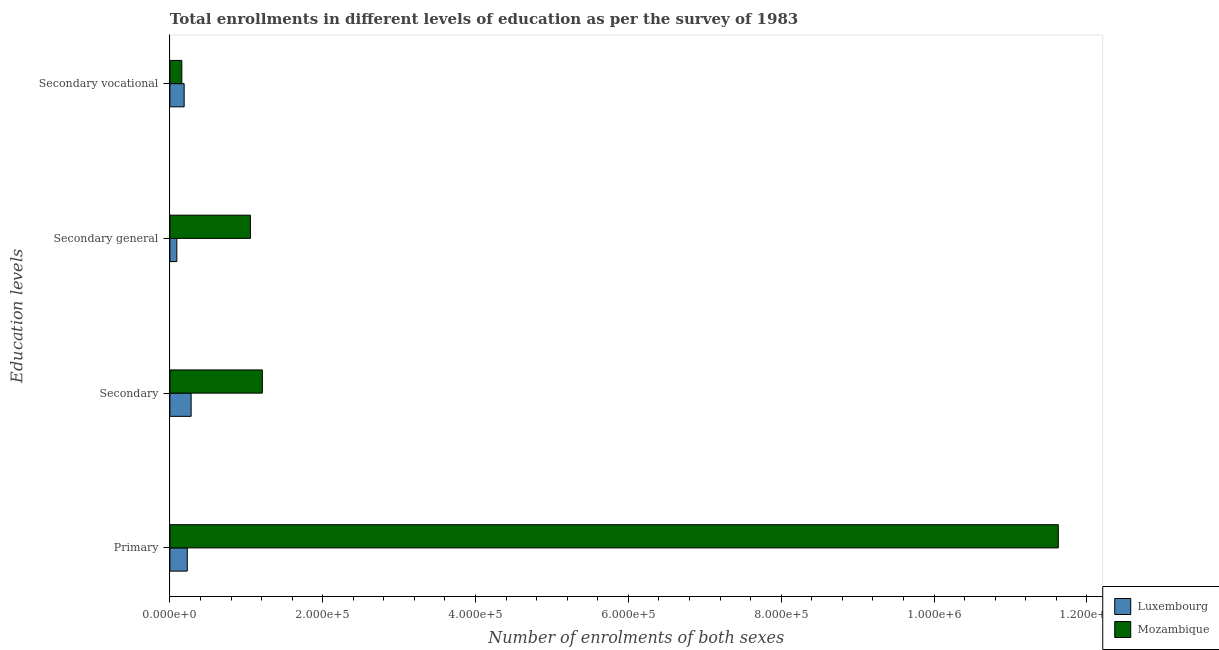Are the number of bars per tick equal to the number of legend labels?
Provide a succinct answer. Yes. Are the number of bars on each tick of the Y-axis equal?
Keep it short and to the point. Yes. How many bars are there on the 2nd tick from the top?
Ensure brevity in your answer.  2. How many bars are there on the 4th tick from the bottom?
Offer a very short reply. 2. What is the label of the 1st group of bars from the top?
Keep it short and to the point. Secondary vocational. What is the number of enrolments in secondary general education in Mozambique?
Provide a short and direct response. 1.05e+05. Across all countries, what is the maximum number of enrolments in primary education?
Keep it short and to the point. 1.16e+06. Across all countries, what is the minimum number of enrolments in primary education?
Offer a terse response. 2.28e+04. In which country was the number of enrolments in secondary general education maximum?
Ensure brevity in your answer.  Mozambique. In which country was the number of enrolments in secondary general education minimum?
Ensure brevity in your answer.  Luxembourg. What is the total number of enrolments in secondary education in the graph?
Your answer should be very brief. 1.49e+05. What is the difference between the number of enrolments in secondary vocational education in Luxembourg and that in Mozambique?
Keep it short and to the point. 3048. What is the difference between the number of enrolments in primary education in Mozambique and the number of enrolments in secondary education in Luxembourg?
Give a very brief answer. 1.13e+06. What is the average number of enrolments in secondary vocational education per country?
Provide a short and direct response. 1.72e+04. What is the difference between the number of enrolments in secondary education and number of enrolments in secondary vocational education in Luxembourg?
Ensure brevity in your answer.  9120. What is the ratio of the number of enrolments in secondary education in Luxembourg to that in Mozambique?
Your response must be concise. 0.23. Is the number of enrolments in secondary vocational education in Luxembourg less than that in Mozambique?
Keep it short and to the point. No. What is the difference between the highest and the second highest number of enrolments in primary education?
Offer a terse response. 1.14e+06. What is the difference between the highest and the lowest number of enrolments in secondary general education?
Provide a short and direct response. 9.63e+04. In how many countries, is the number of enrolments in primary education greater than the average number of enrolments in primary education taken over all countries?
Ensure brevity in your answer.  1. Is the sum of the number of enrolments in secondary vocational education in Mozambique and Luxembourg greater than the maximum number of enrolments in primary education across all countries?
Provide a succinct answer. No. Is it the case that in every country, the sum of the number of enrolments in secondary education and number of enrolments in primary education is greater than the sum of number of enrolments in secondary general education and number of enrolments in secondary vocational education?
Offer a very short reply. No. What does the 1st bar from the top in Secondary vocational represents?
Offer a very short reply. Mozambique. What does the 2nd bar from the bottom in Secondary represents?
Your answer should be very brief. Mozambique. Is it the case that in every country, the sum of the number of enrolments in primary education and number of enrolments in secondary education is greater than the number of enrolments in secondary general education?
Your response must be concise. Yes. How many bars are there?
Give a very brief answer. 8. How many countries are there in the graph?
Offer a terse response. 2. What is the difference between two consecutive major ticks on the X-axis?
Your answer should be very brief. 2.00e+05. Does the graph contain grids?
Your answer should be very brief. No. Where does the legend appear in the graph?
Offer a terse response. Bottom right. How many legend labels are there?
Your answer should be very brief. 2. How are the legend labels stacked?
Offer a very short reply. Vertical. What is the title of the graph?
Your answer should be compact. Total enrollments in different levels of education as per the survey of 1983. Does "Azerbaijan" appear as one of the legend labels in the graph?
Provide a succinct answer. No. What is the label or title of the X-axis?
Offer a terse response. Number of enrolments of both sexes. What is the label or title of the Y-axis?
Give a very brief answer. Education levels. What is the Number of enrolments of both sexes of Luxembourg in Primary?
Your response must be concise. 2.28e+04. What is the Number of enrolments of both sexes of Mozambique in Primary?
Keep it short and to the point. 1.16e+06. What is the Number of enrolments of both sexes of Luxembourg in Secondary?
Keep it short and to the point. 2.78e+04. What is the Number of enrolments of both sexes of Mozambique in Secondary?
Offer a very short reply. 1.21e+05. What is the Number of enrolments of both sexes in Luxembourg in Secondary general?
Your response must be concise. 9120. What is the Number of enrolments of both sexes in Mozambique in Secondary general?
Keep it short and to the point. 1.05e+05. What is the Number of enrolments of both sexes in Luxembourg in Secondary vocational?
Give a very brief answer. 1.87e+04. What is the Number of enrolments of both sexes in Mozambique in Secondary vocational?
Your answer should be very brief. 1.56e+04. Across all Education levels, what is the maximum Number of enrolments of both sexes of Luxembourg?
Offer a very short reply. 2.78e+04. Across all Education levels, what is the maximum Number of enrolments of both sexes of Mozambique?
Your answer should be compact. 1.16e+06. Across all Education levels, what is the minimum Number of enrolments of both sexes of Luxembourg?
Your response must be concise. 9120. Across all Education levels, what is the minimum Number of enrolments of both sexes in Mozambique?
Offer a terse response. 1.56e+04. What is the total Number of enrolments of both sexes in Luxembourg in the graph?
Make the answer very short. 7.84e+04. What is the total Number of enrolments of both sexes in Mozambique in the graph?
Provide a short and direct response. 1.40e+06. What is the difference between the Number of enrolments of both sexes of Luxembourg in Primary and that in Secondary?
Ensure brevity in your answer.  -5026. What is the difference between the Number of enrolments of both sexes of Mozambique in Primary and that in Secondary?
Offer a terse response. 1.04e+06. What is the difference between the Number of enrolments of both sexes of Luxembourg in Primary and that in Secondary general?
Ensure brevity in your answer.  1.37e+04. What is the difference between the Number of enrolments of both sexes in Mozambique in Primary and that in Secondary general?
Your answer should be compact. 1.06e+06. What is the difference between the Number of enrolments of both sexes of Luxembourg in Primary and that in Secondary vocational?
Offer a terse response. 4094. What is the difference between the Number of enrolments of both sexes in Mozambique in Primary and that in Secondary vocational?
Your answer should be compact. 1.15e+06. What is the difference between the Number of enrolments of both sexes in Luxembourg in Secondary and that in Secondary general?
Your answer should be very brief. 1.87e+04. What is the difference between the Number of enrolments of both sexes of Mozambique in Secondary and that in Secondary general?
Your answer should be compact. 1.56e+04. What is the difference between the Number of enrolments of both sexes of Luxembourg in Secondary and that in Secondary vocational?
Keep it short and to the point. 9120. What is the difference between the Number of enrolments of both sexes of Mozambique in Secondary and that in Secondary vocational?
Provide a succinct answer. 1.05e+05. What is the difference between the Number of enrolments of both sexes in Luxembourg in Secondary general and that in Secondary vocational?
Keep it short and to the point. -9566. What is the difference between the Number of enrolments of both sexes in Mozambique in Secondary general and that in Secondary vocational?
Make the answer very short. 8.98e+04. What is the difference between the Number of enrolments of both sexes in Luxembourg in Primary and the Number of enrolments of both sexes in Mozambique in Secondary?
Offer a terse response. -9.83e+04. What is the difference between the Number of enrolments of both sexes in Luxembourg in Primary and the Number of enrolments of both sexes in Mozambique in Secondary general?
Your response must be concise. -8.26e+04. What is the difference between the Number of enrolments of both sexes in Luxembourg in Primary and the Number of enrolments of both sexes in Mozambique in Secondary vocational?
Offer a terse response. 7142. What is the difference between the Number of enrolments of both sexes of Luxembourg in Secondary and the Number of enrolments of both sexes of Mozambique in Secondary general?
Keep it short and to the point. -7.76e+04. What is the difference between the Number of enrolments of both sexes of Luxembourg in Secondary and the Number of enrolments of both sexes of Mozambique in Secondary vocational?
Offer a terse response. 1.22e+04. What is the difference between the Number of enrolments of both sexes of Luxembourg in Secondary general and the Number of enrolments of both sexes of Mozambique in Secondary vocational?
Offer a terse response. -6518. What is the average Number of enrolments of both sexes in Luxembourg per Education levels?
Ensure brevity in your answer.  1.96e+04. What is the average Number of enrolments of both sexes in Mozambique per Education levels?
Offer a terse response. 3.51e+05. What is the difference between the Number of enrolments of both sexes of Luxembourg and Number of enrolments of both sexes of Mozambique in Primary?
Offer a very short reply. -1.14e+06. What is the difference between the Number of enrolments of both sexes in Luxembourg and Number of enrolments of both sexes in Mozambique in Secondary?
Offer a terse response. -9.32e+04. What is the difference between the Number of enrolments of both sexes in Luxembourg and Number of enrolments of both sexes in Mozambique in Secondary general?
Provide a succinct answer. -9.63e+04. What is the difference between the Number of enrolments of both sexes in Luxembourg and Number of enrolments of both sexes in Mozambique in Secondary vocational?
Offer a terse response. 3048. What is the ratio of the Number of enrolments of both sexes of Luxembourg in Primary to that in Secondary?
Offer a very short reply. 0.82. What is the ratio of the Number of enrolments of both sexes of Mozambique in Primary to that in Secondary?
Give a very brief answer. 9.61. What is the ratio of the Number of enrolments of both sexes of Luxembourg in Primary to that in Secondary general?
Keep it short and to the point. 2.5. What is the ratio of the Number of enrolments of both sexes of Mozambique in Primary to that in Secondary general?
Offer a very short reply. 11.03. What is the ratio of the Number of enrolments of both sexes of Luxembourg in Primary to that in Secondary vocational?
Provide a succinct answer. 1.22. What is the ratio of the Number of enrolments of both sexes of Mozambique in Primary to that in Secondary vocational?
Make the answer very short. 74.35. What is the ratio of the Number of enrolments of both sexes of Luxembourg in Secondary to that in Secondary general?
Offer a very short reply. 3.05. What is the ratio of the Number of enrolments of both sexes of Mozambique in Secondary to that in Secondary general?
Provide a short and direct response. 1.15. What is the ratio of the Number of enrolments of both sexes of Luxembourg in Secondary to that in Secondary vocational?
Give a very brief answer. 1.49. What is the ratio of the Number of enrolments of both sexes of Mozambique in Secondary to that in Secondary vocational?
Keep it short and to the point. 7.74. What is the ratio of the Number of enrolments of both sexes in Luxembourg in Secondary general to that in Secondary vocational?
Offer a very short reply. 0.49. What is the ratio of the Number of enrolments of both sexes in Mozambique in Secondary general to that in Secondary vocational?
Make the answer very short. 6.74. What is the difference between the highest and the second highest Number of enrolments of both sexes of Luxembourg?
Provide a succinct answer. 5026. What is the difference between the highest and the second highest Number of enrolments of both sexes of Mozambique?
Provide a short and direct response. 1.04e+06. What is the difference between the highest and the lowest Number of enrolments of both sexes in Luxembourg?
Give a very brief answer. 1.87e+04. What is the difference between the highest and the lowest Number of enrolments of both sexes of Mozambique?
Provide a short and direct response. 1.15e+06. 